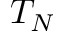<formula> <loc_0><loc_0><loc_500><loc_500>T _ { N }</formula> 